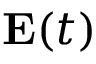Convert formula to latex. <formula><loc_0><loc_0><loc_500><loc_500>E ( t )</formula> 